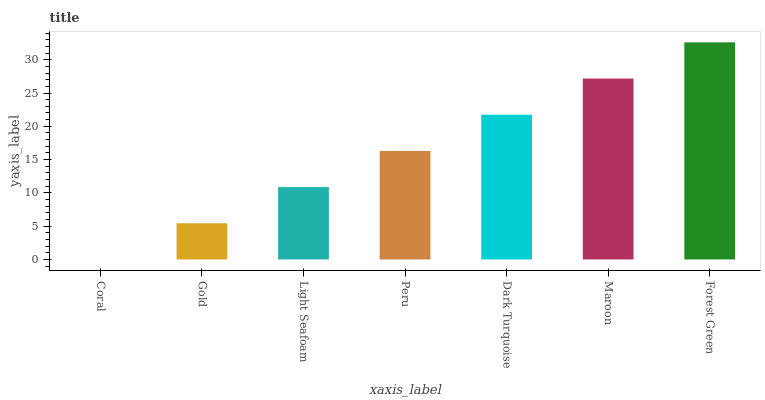Is Coral the minimum?
Answer yes or no. Yes. Is Forest Green the maximum?
Answer yes or no. Yes. Is Gold the minimum?
Answer yes or no. No. Is Gold the maximum?
Answer yes or no. No. Is Gold greater than Coral?
Answer yes or no. Yes. Is Coral less than Gold?
Answer yes or no. Yes. Is Coral greater than Gold?
Answer yes or no. No. Is Gold less than Coral?
Answer yes or no. No. Is Peru the high median?
Answer yes or no. Yes. Is Peru the low median?
Answer yes or no. Yes. Is Dark Turquoise the high median?
Answer yes or no. No. Is Dark Turquoise the low median?
Answer yes or no. No. 